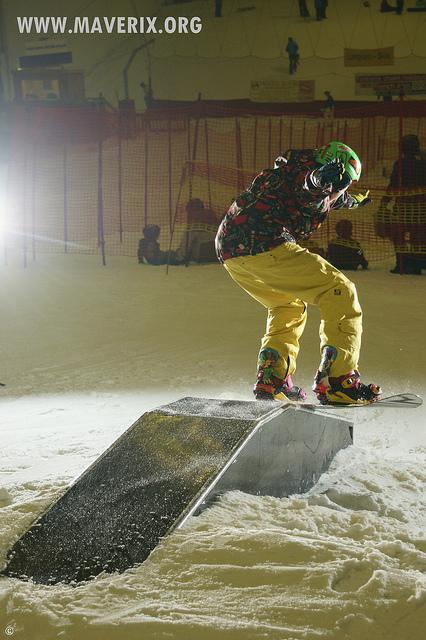What is the man doing?
Quick response, please. Snowboarding. What covers the ground?
Write a very short answer. Snow. Is there anyone else in the picture?
Short answer required. Yes. 